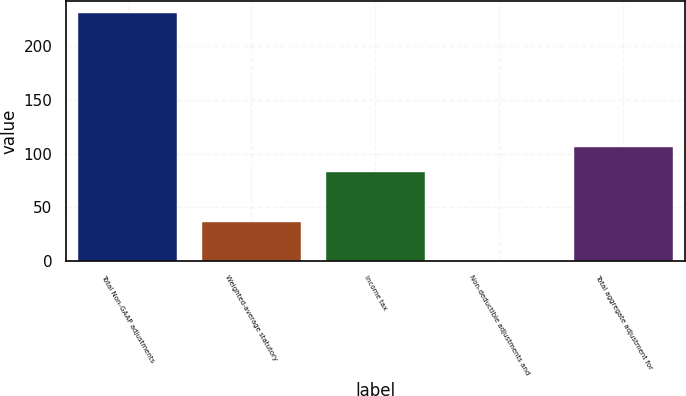Convert chart to OTSL. <chart><loc_0><loc_0><loc_500><loc_500><bar_chart><fcel>Total Non-GAAP adjustments<fcel>Weighted-average statutory<fcel>Income tax<fcel>Non-deductible adjustments and<fcel>Total aggregate adjustment for<nl><fcel>230.4<fcel>36<fcel>82.9<fcel>0.4<fcel>105.9<nl></chart> 